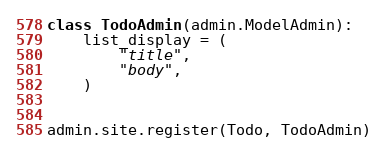Convert code to text. <code><loc_0><loc_0><loc_500><loc_500><_Python_>

class TodoAdmin(admin.ModelAdmin):
    list_display = (
        "title",
        "body",
    )


admin.site.register(Todo, TodoAdmin)
</code> 